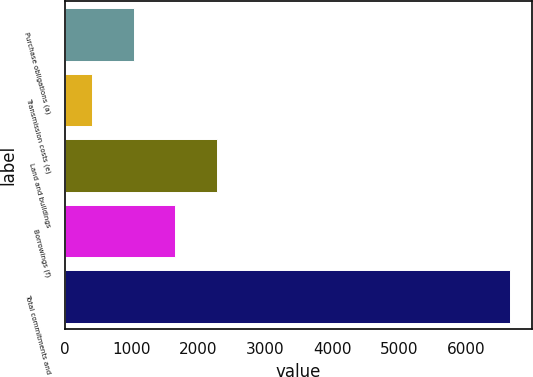Convert chart to OTSL. <chart><loc_0><loc_0><loc_500><loc_500><bar_chart><fcel>Purchase obligations (a)<fcel>Transmission costs (e)<fcel>Land and buildings<fcel>Borrowings (f)<fcel>Total commitments and<nl><fcel>1033.4<fcel>408<fcel>2284.2<fcel>1658.8<fcel>6662<nl></chart> 